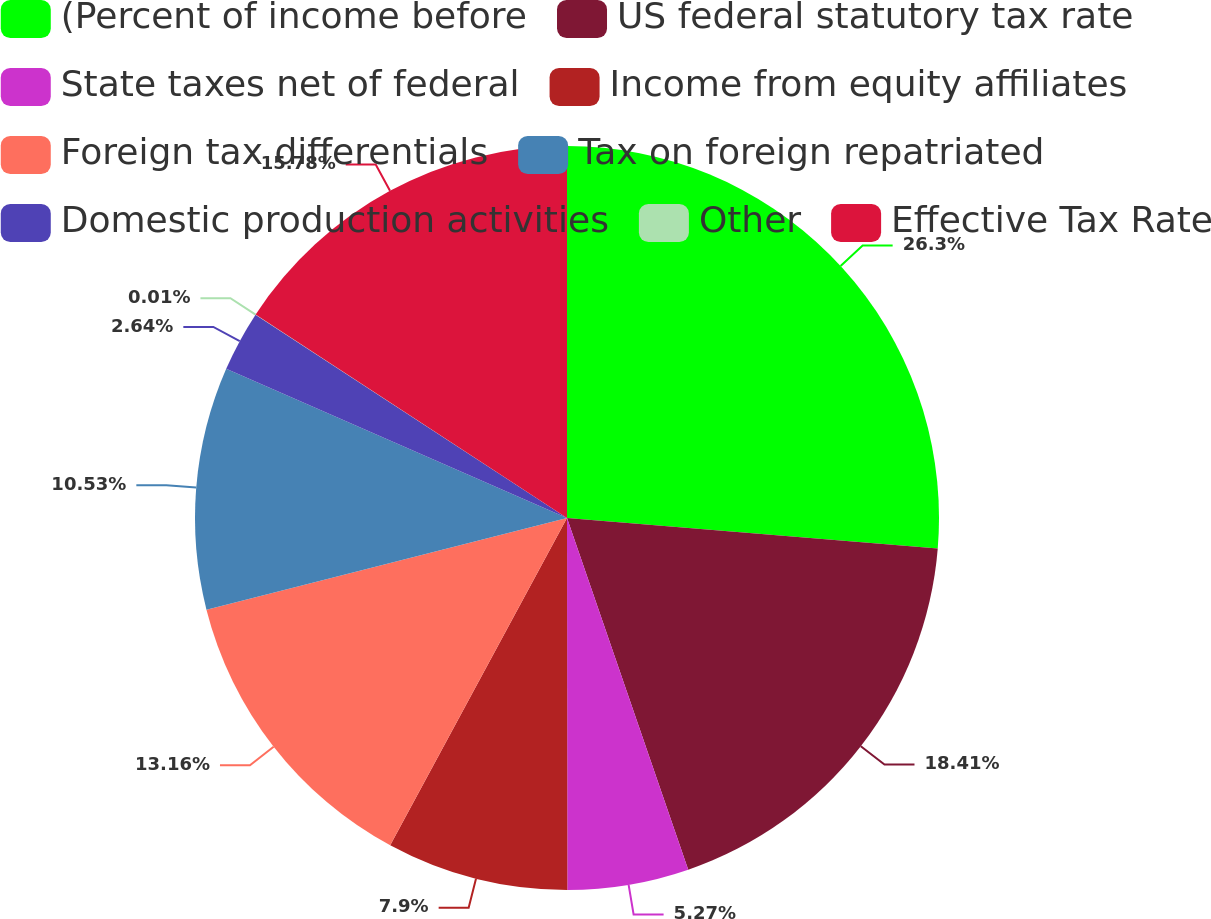<chart> <loc_0><loc_0><loc_500><loc_500><pie_chart><fcel>(Percent of income before<fcel>US federal statutory tax rate<fcel>State taxes net of federal<fcel>Income from equity affiliates<fcel>Foreign tax differentials<fcel>Tax on foreign repatriated<fcel>Domestic production activities<fcel>Other<fcel>Effective Tax Rate<nl><fcel>26.31%<fcel>18.42%<fcel>5.27%<fcel>7.9%<fcel>13.16%<fcel>10.53%<fcel>2.64%<fcel>0.01%<fcel>15.79%<nl></chart> 